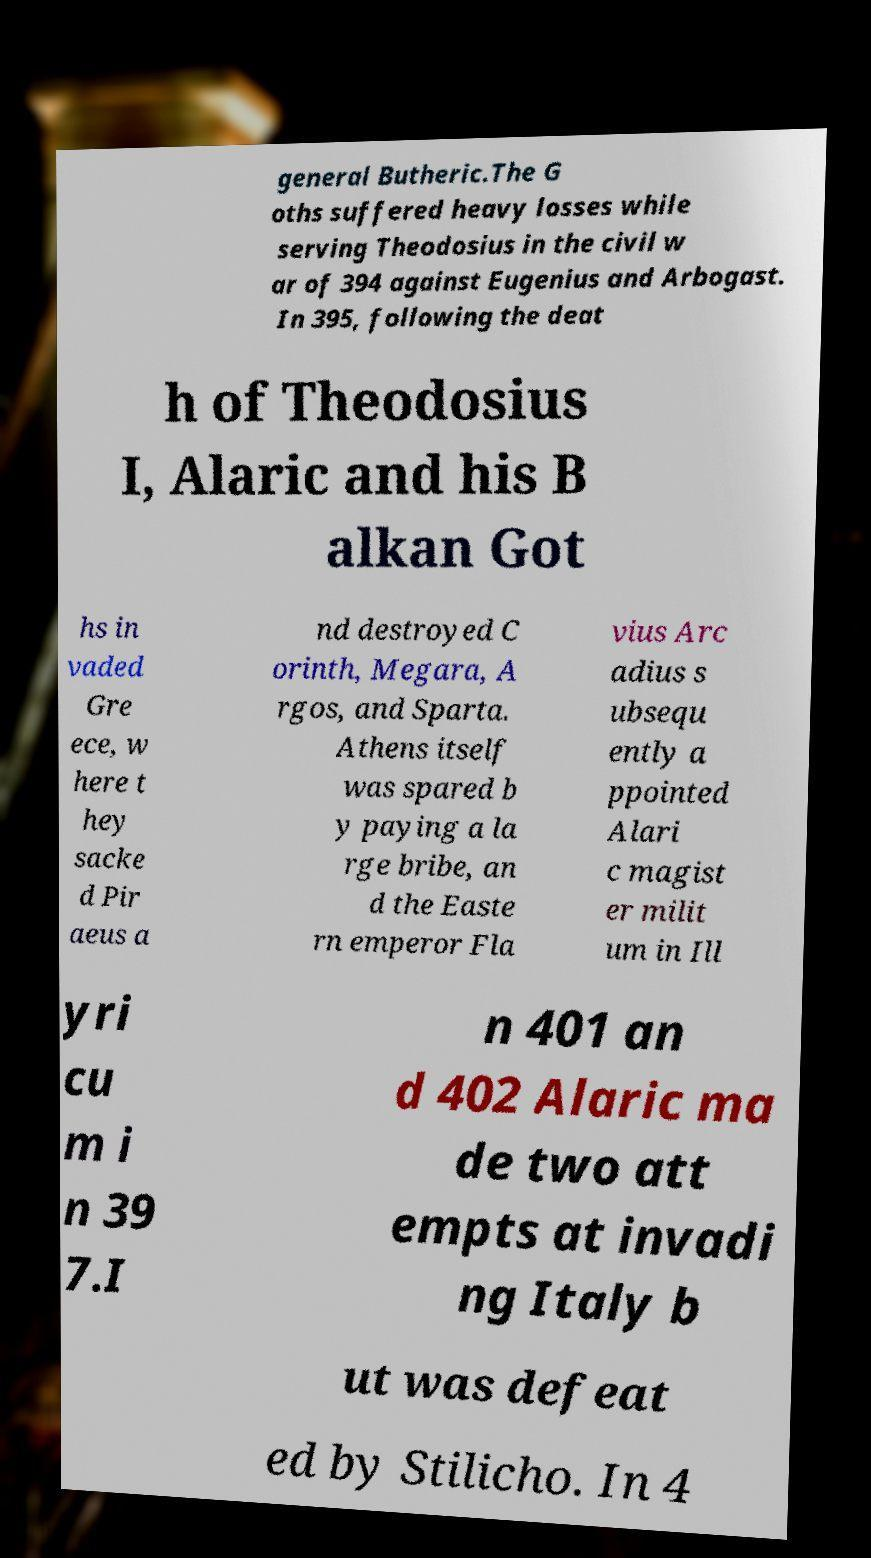There's text embedded in this image that I need extracted. Can you transcribe it verbatim? general Butheric.The G oths suffered heavy losses while serving Theodosius in the civil w ar of 394 against Eugenius and Arbogast. In 395, following the deat h of Theodosius I, Alaric and his B alkan Got hs in vaded Gre ece, w here t hey sacke d Pir aeus a nd destroyed C orinth, Megara, A rgos, and Sparta. Athens itself was spared b y paying a la rge bribe, an d the Easte rn emperor Fla vius Arc adius s ubsequ ently a ppointed Alari c magist er milit um in Ill yri cu m i n 39 7.I n 401 an d 402 Alaric ma de two att empts at invadi ng Italy b ut was defeat ed by Stilicho. In 4 